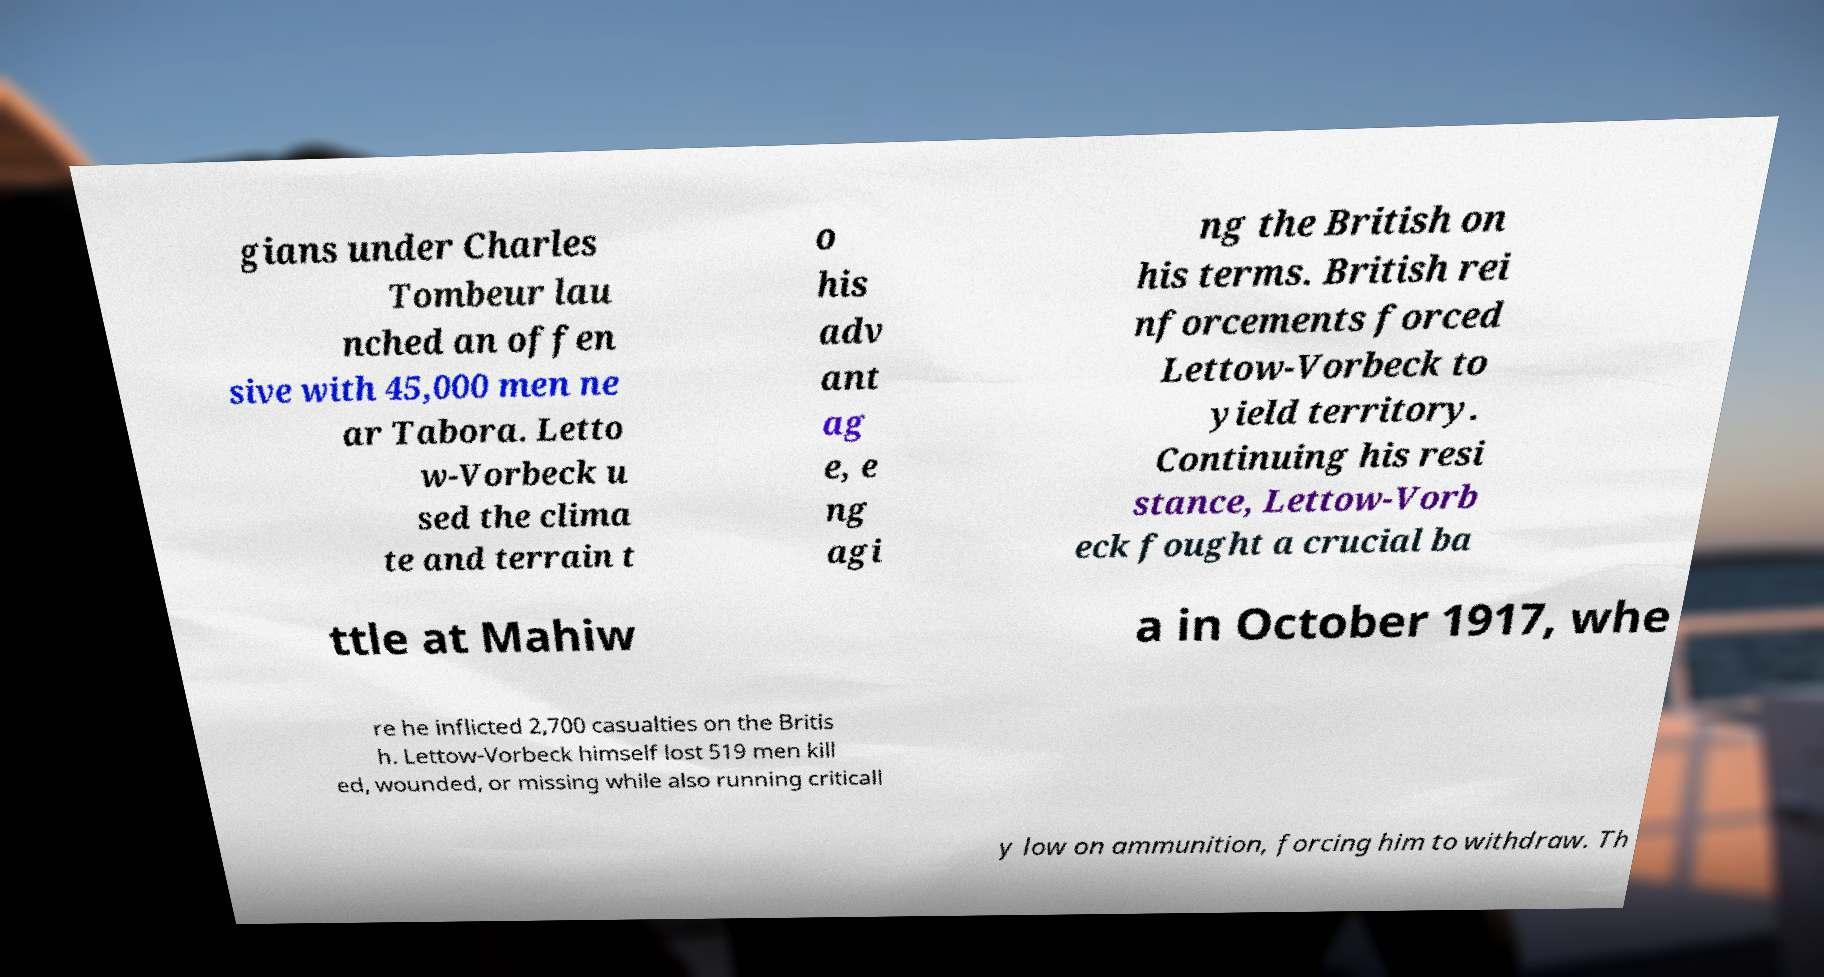Can you accurately transcribe the text from the provided image for me? gians under Charles Tombeur lau nched an offen sive with 45,000 men ne ar Tabora. Letto w-Vorbeck u sed the clima te and terrain t o his adv ant ag e, e ng agi ng the British on his terms. British rei nforcements forced Lettow-Vorbeck to yield territory. Continuing his resi stance, Lettow-Vorb eck fought a crucial ba ttle at Mahiw a in October 1917, whe re he inflicted 2,700 casualties on the Britis h. Lettow-Vorbeck himself lost 519 men kill ed, wounded, or missing while also running criticall y low on ammunition, forcing him to withdraw. Th 